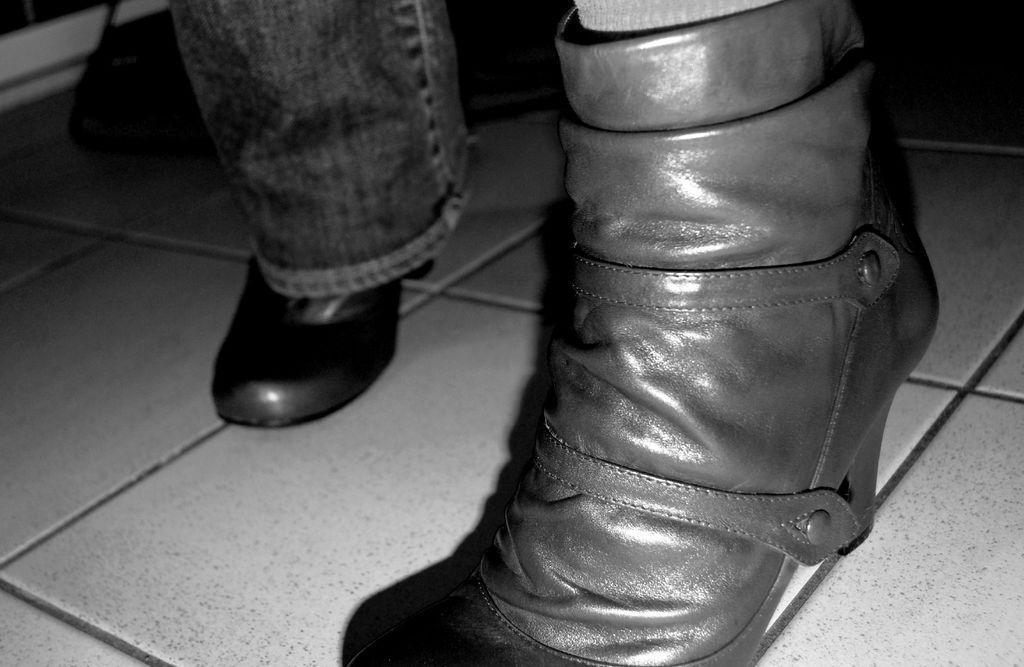Can you describe this image briefly? This is a black and white picture. I can see jeans, there are shoes on the floor. 